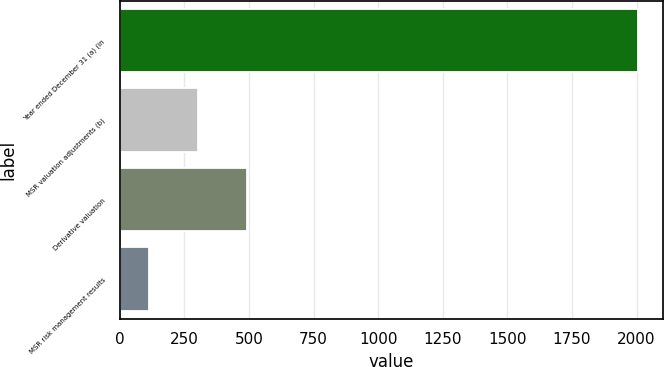<chart> <loc_0><loc_0><loc_500><loc_500><bar_chart><fcel>Year ended December 31 (a) (in<fcel>MSR valuation adjustments (b)<fcel>Derivative valuation<fcel>MSR risk management results<nl><fcel>2004<fcel>302.1<fcel>491.2<fcel>113<nl></chart> 